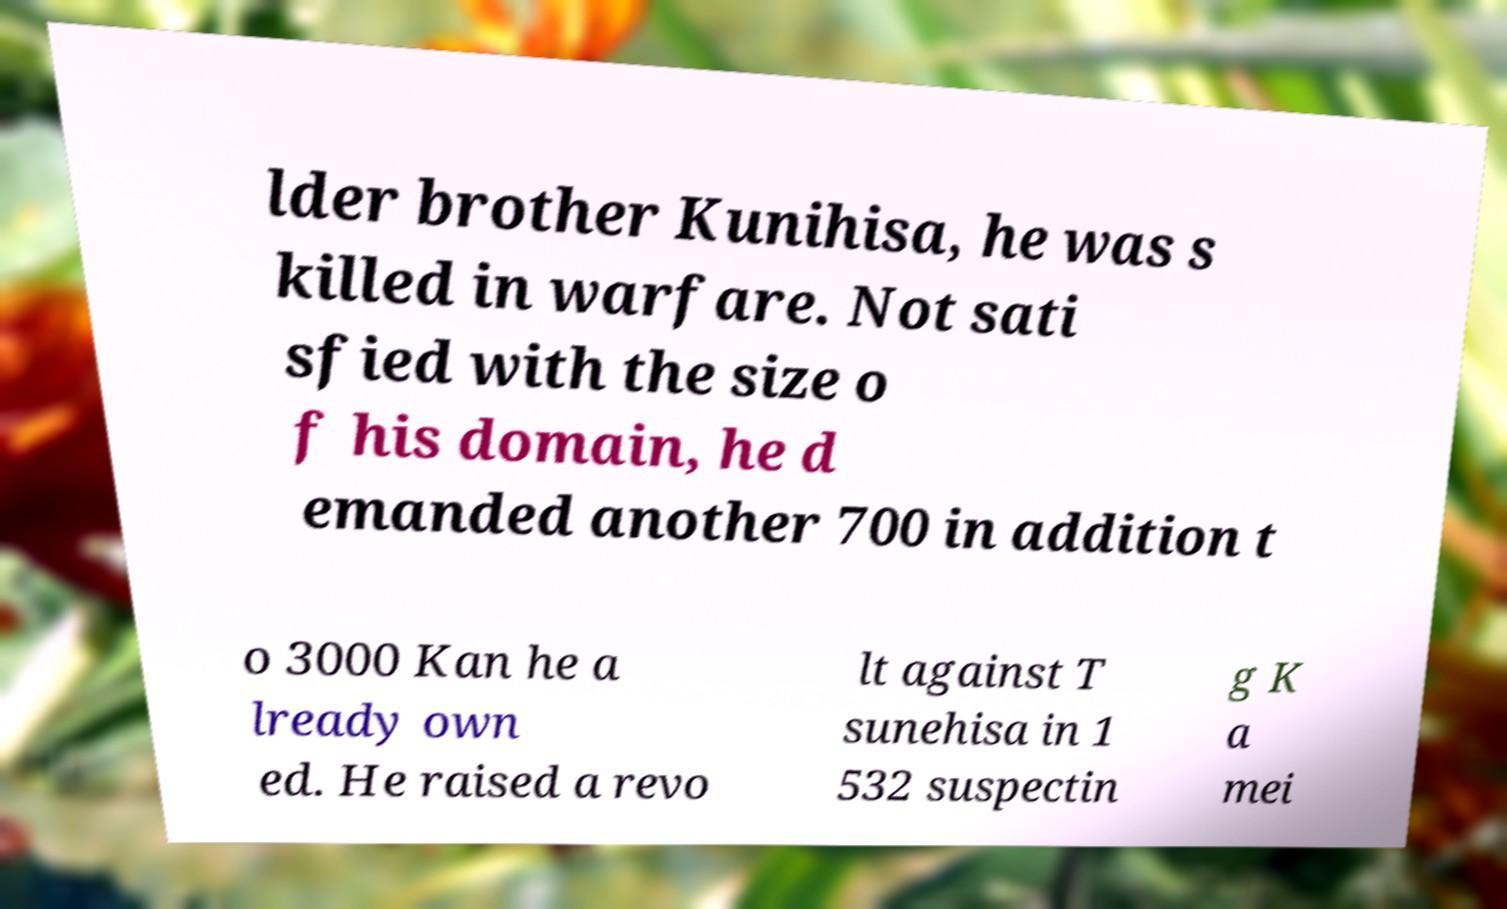I need the written content from this picture converted into text. Can you do that? lder brother Kunihisa, he was s killed in warfare. Not sati sfied with the size o f his domain, he d emanded another 700 in addition t o 3000 Kan he a lready own ed. He raised a revo lt against T sunehisa in 1 532 suspectin g K a mei 